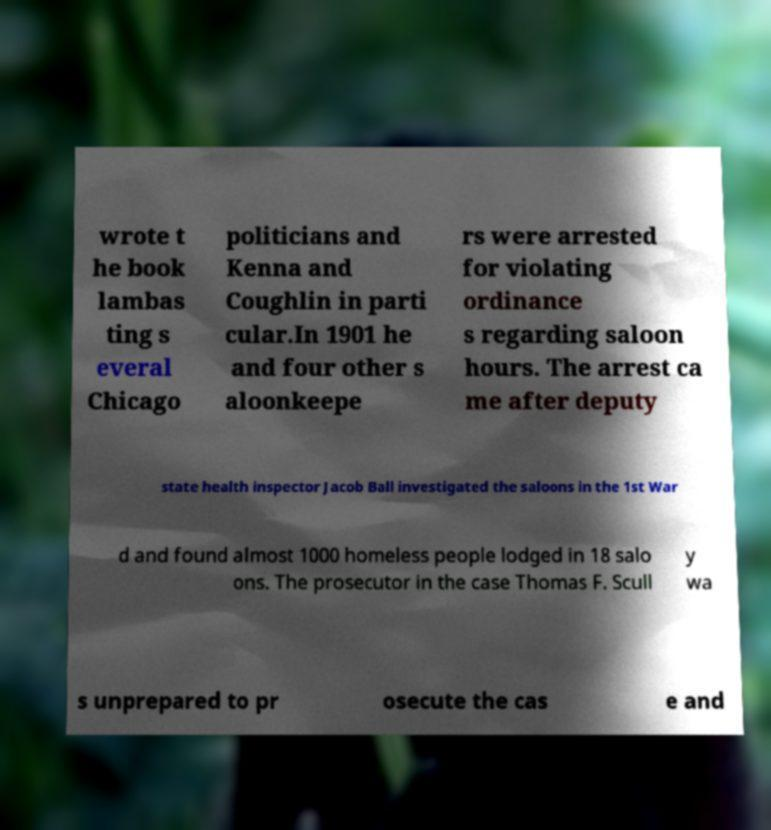For documentation purposes, I need the text within this image transcribed. Could you provide that? wrote t he book lambas ting s everal Chicago politicians and Kenna and Coughlin in parti cular.In 1901 he and four other s aloonkeepe rs were arrested for violating ordinance s regarding saloon hours. The arrest ca me after deputy state health inspector Jacob Ball investigated the saloons in the 1st War d and found almost 1000 homeless people lodged in 18 salo ons. The prosecutor in the case Thomas F. Scull y wa s unprepared to pr osecute the cas e and 